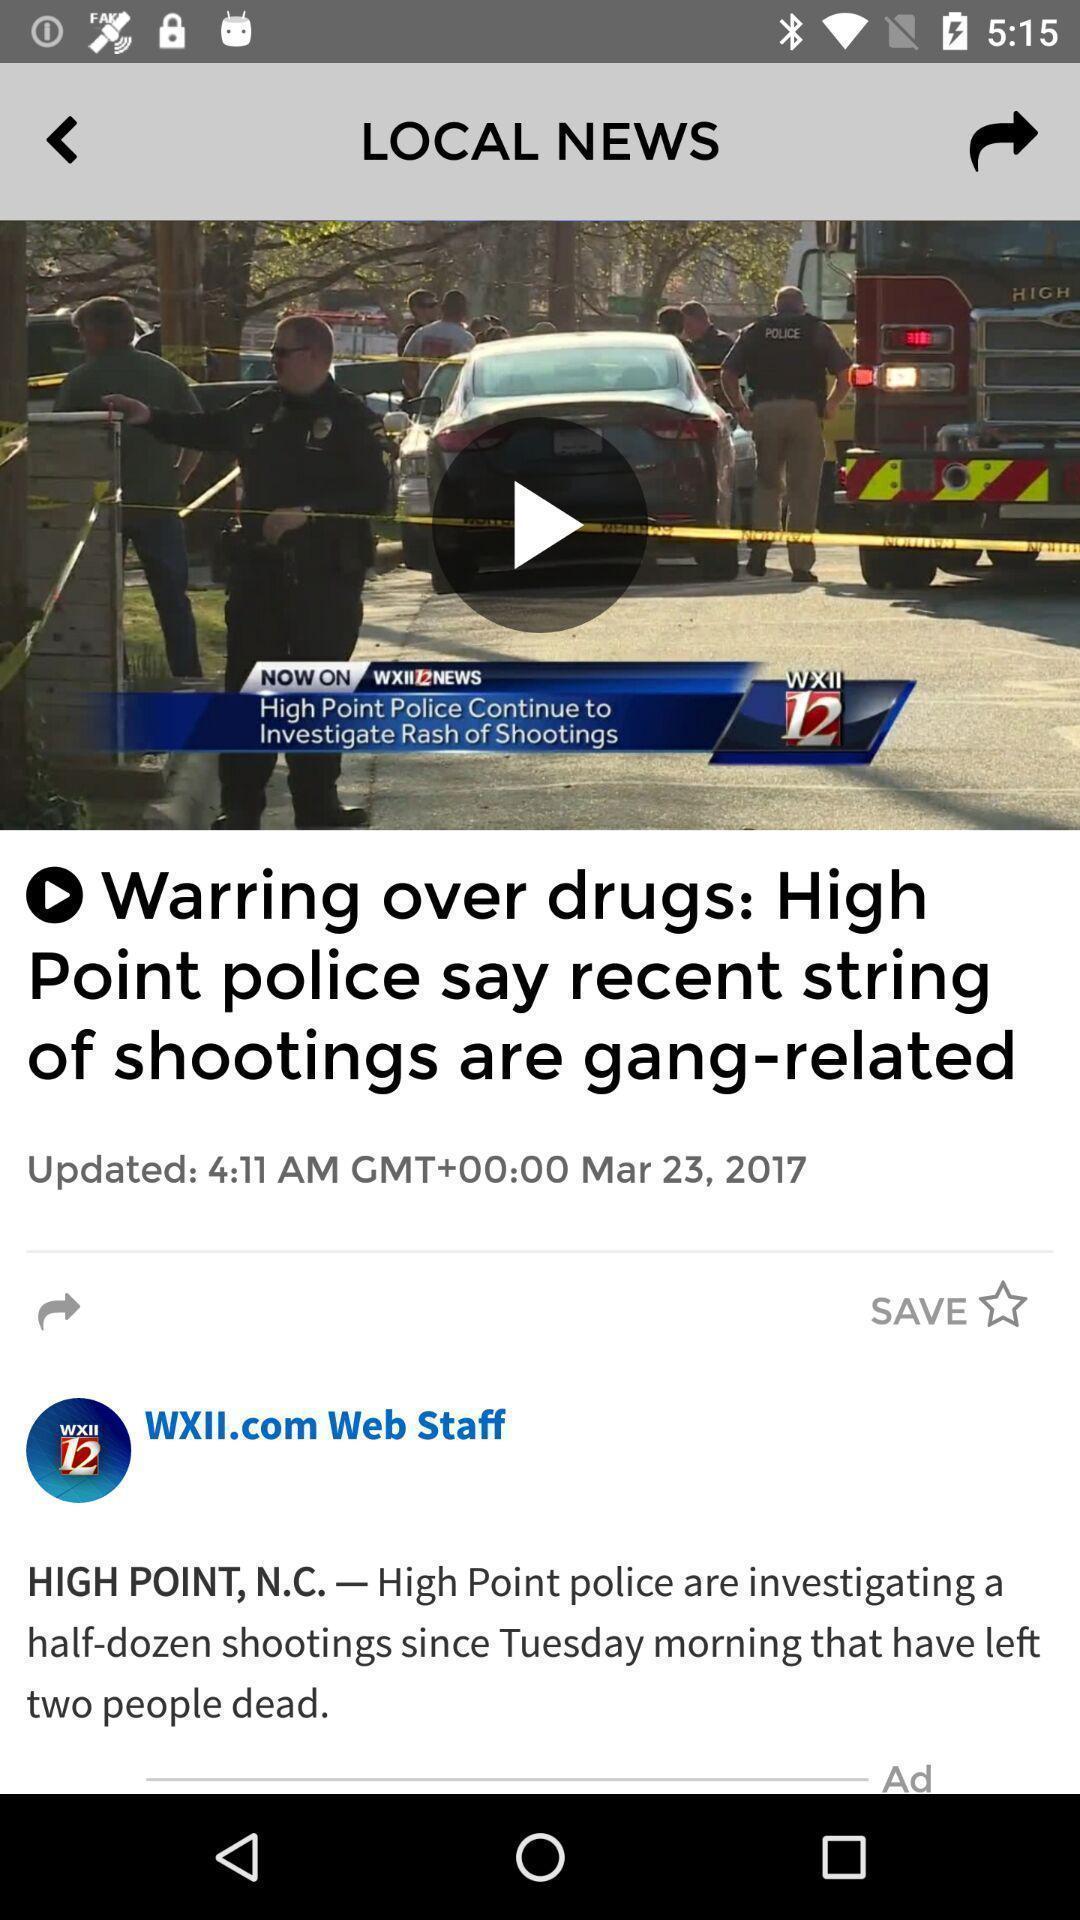Tell me about the visual elements in this screen capture. Screen showing local news. 